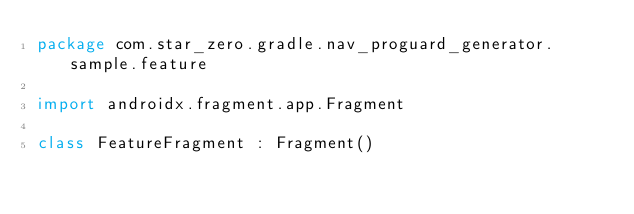<code> <loc_0><loc_0><loc_500><loc_500><_Kotlin_>package com.star_zero.gradle.nav_proguard_generator.sample.feature

import androidx.fragment.app.Fragment

class FeatureFragment : Fragment()
</code> 